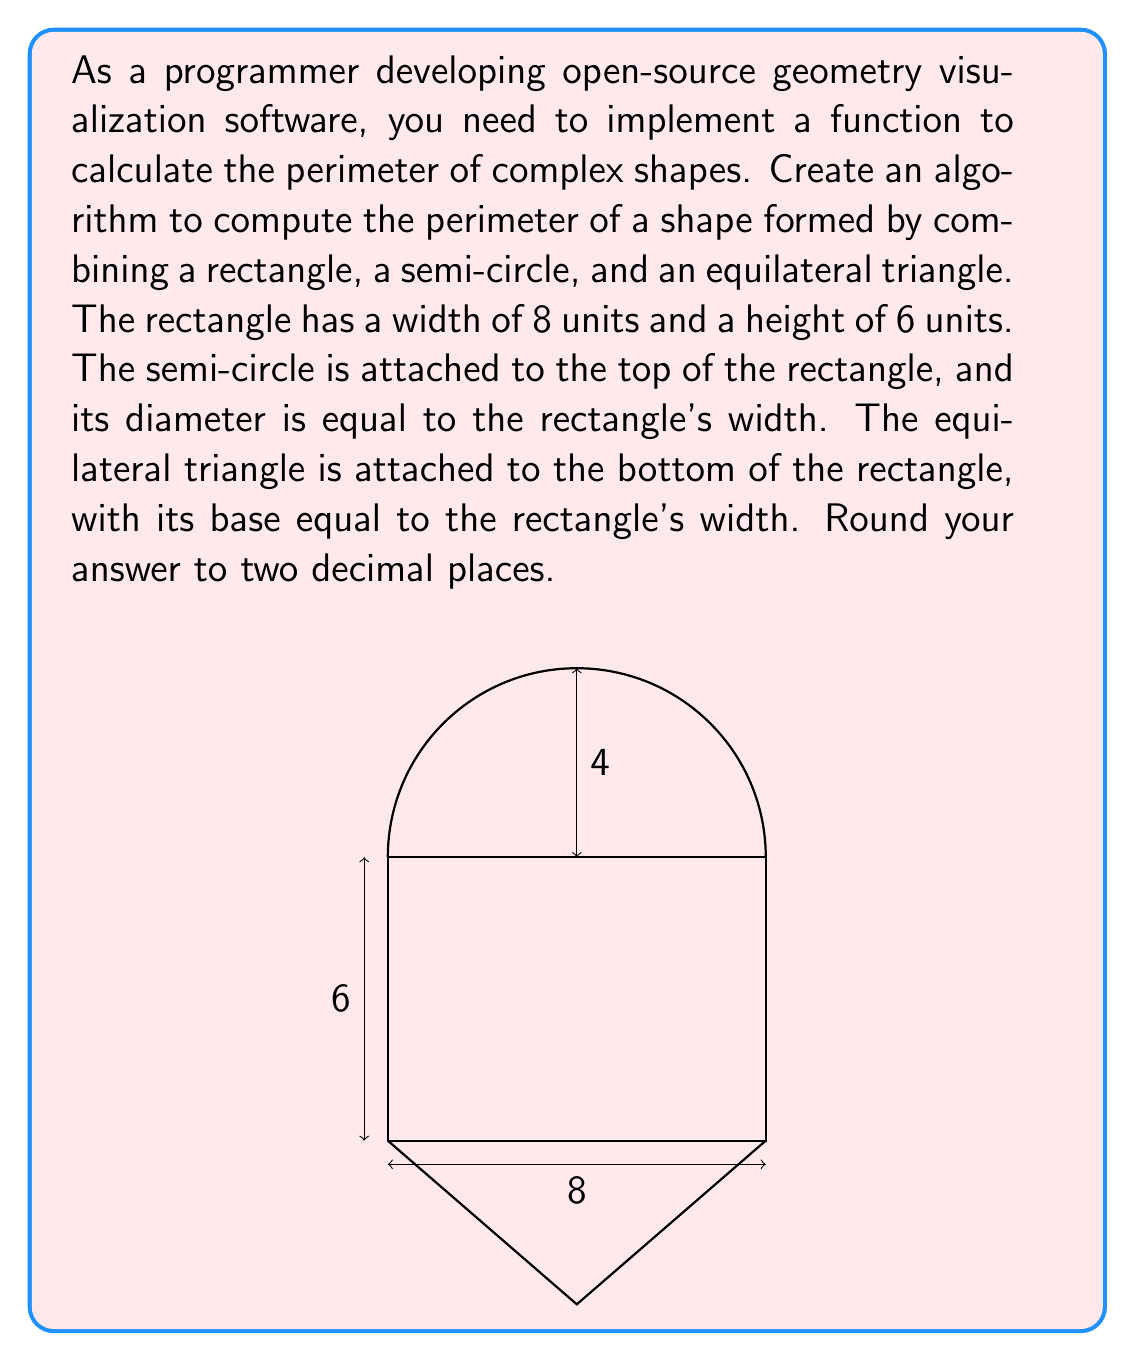Solve this math problem. To calculate the perimeter of this complex shape, we need to add up the lengths of all its outer edges:

1. Rectangle:
   - We only need two sides of the rectangle (left and right), as the top and bottom are connected to other shapes.
   - Perimeter contribution: $2 \cdot 6 = 12$ units

2. Semi-circle:
   - The semi-circle's diameter is equal to the rectangle's width (8 units).
   - Its radius is therefore 4 units.
   - The length of a semi-circle is given by $\pi r$
   - Perimeter contribution: $\pi \cdot 4 = 4\pi$ units

3. Equilateral triangle:
   - The base of the triangle is equal to the rectangle's width (8 units).
   - In an equilateral triangle, all sides are equal.
   - To find the side length, we can use the Pythagorean theorem:
     $$ a^2 = 8^2 + (\frac{8\sqrt{3}}{2})^2 $$
     $$ a^2 = 64 + 48 = 112 $$
     $$ a = \sqrt{112} = 4\sqrt{7} $$
   - We need two sides of the triangle (as the base is connected to the rectangle).
   - Perimeter contribution: $2 \cdot 4\sqrt{7}$ units

Total perimeter:
$$ 12 + 4\pi + 8\sqrt{7} $$

Calculating and rounding to two decimal places:
$$ 12 + 4 \cdot 3.14159... + 8 \cdot 2.64575... \approx 45.88 $$
Answer: 45.88 units 